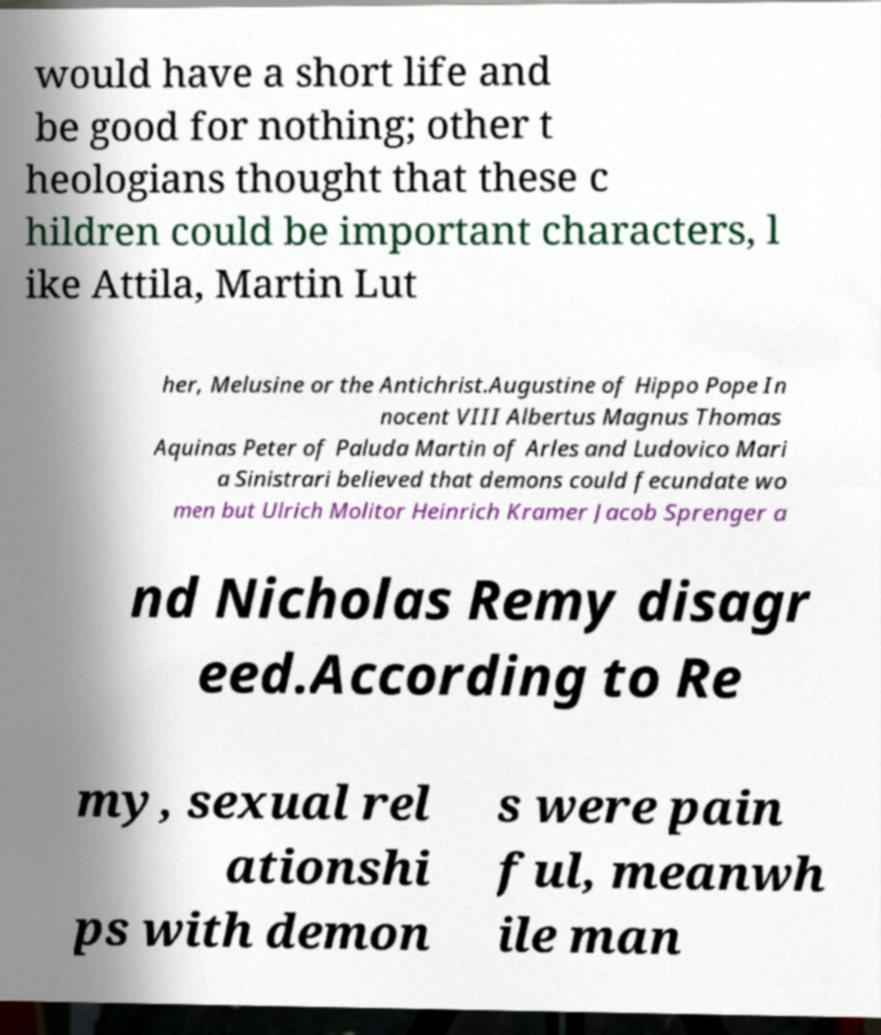Please identify and transcribe the text found in this image. would have a short life and be good for nothing; other t heologians thought that these c hildren could be important characters, l ike Attila, Martin Lut her, Melusine or the Antichrist.Augustine of Hippo Pope In nocent VIII Albertus Magnus Thomas Aquinas Peter of Paluda Martin of Arles and Ludovico Mari a Sinistrari believed that demons could fecundate wo men but Ulrich Molitor Heinrich Kramer Jacob Sprenger a nd Nicholas Remy disagr eed.According to Re my, sexual rel ationshi ps with demon s were pain ful, meanwh ile man 